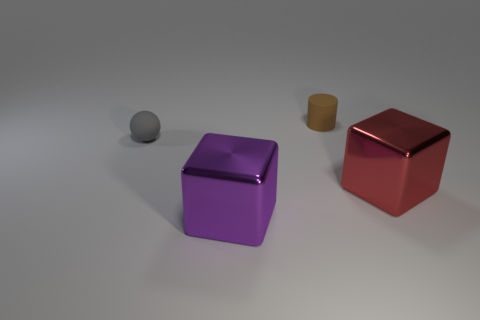What number of large purple metal things have the same shape as the big red shiny thing? There is one large purple object that shares the same cubic shape as the big red object. It appears to be made of the same matte-metallic material and reflects light similarly, suggesting they are of comparable substance and finish. 